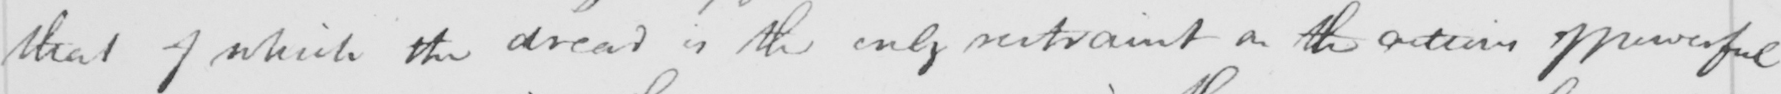Can you tell me what this handwritten text says? that of which the dread is the only restraint on the actions of powerful 